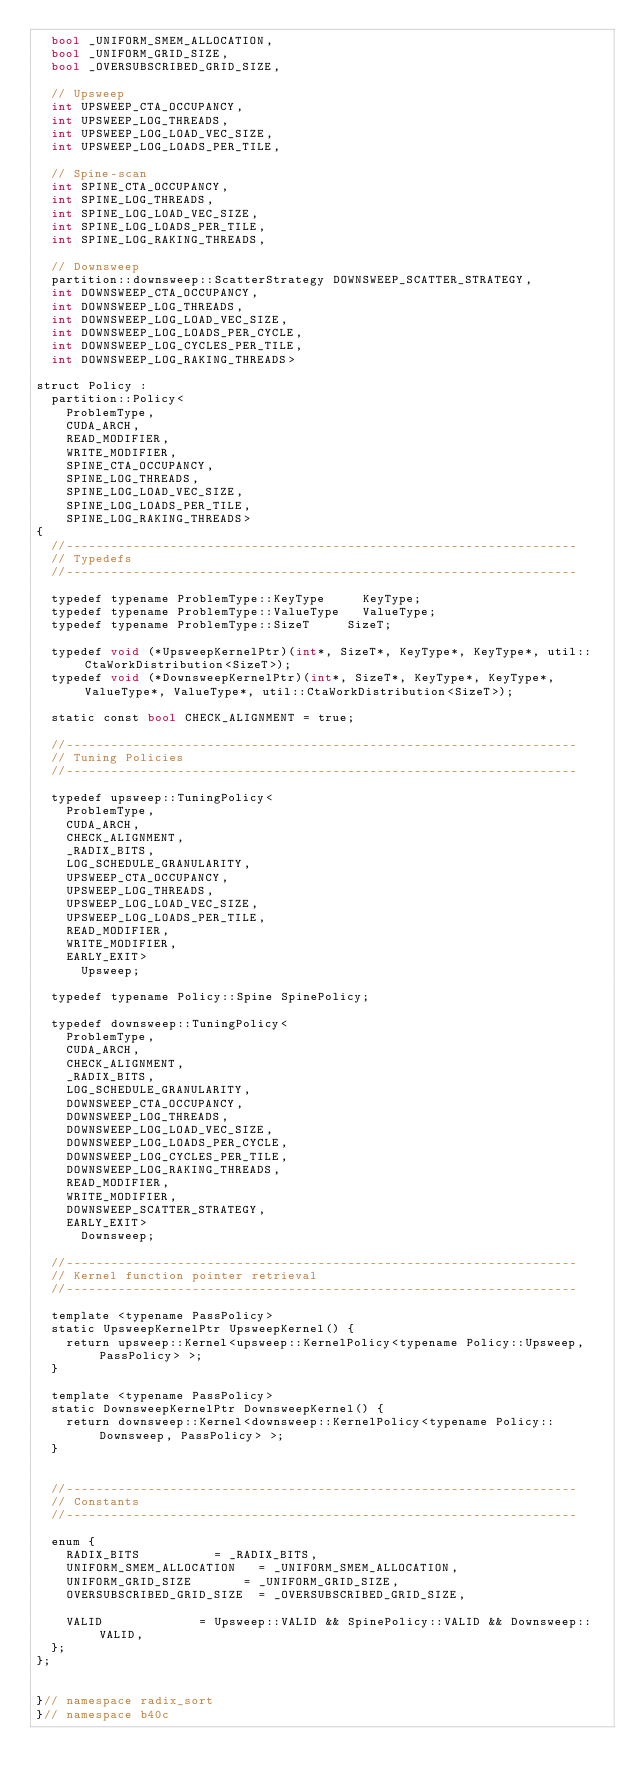<code> <loc_0><loc_0><loc_500><loc_500><_Cuda_>	bool _UNIFORM_SMEM_ALLOCATION,
	bool _UNIFORM_GRID_SIZE,
	bool _OVERSUBSCRIBED_GRID_SIZE,
	
	// Upsweep
	int UPSWEEP_CTA_OCCUPANCY,
	int UPSWEEP_LOG_THREADS,
	int UPSWEEP_LOG_LOAD_VEC_SIZE,
	int UPSWEEP_LOG_LOADS_PER_TILE,
	
	// Spine-scan
	int SPINE_CTA_OCCUPANCY,
	int SPINE_LOG_THREADS,
	int SPINE_LOG_LOAD_VEC_SIZE,
	int SPINE_LOG_LOADS_PER_TILE,
	int SPINE_LOG_RAKING_THREADS,

	// Downsweep
	partition::downsweep::ScatterStrategy DOWNSWEEP_SCATTER_STRATEGY,
	int DOWNSWEEP_CTA_OCCUPANCY,
	int DOWNSWEEP_LOG_THREADS,
	int DOWNSWEEP_LOG_LOAD_VEC_SIZE,
	int DOWNSWEEP_LOG_LOADS_PER_CYCLE,
	int DOWNSWEEP_LOG_CYCLES_PER_TILE,
	int DOWNSWEEP_LOG_RAKING_THREADS>

struct Policy :
	partition::Policy<
		ProblemType,
		CUDA_ARCH,
		READ_MODIFIER,
		WRITE_MODIFIER,
		SPINE_CTA_OCCUPANCY,
		SPINE_LOG_THREADS,
		SPINE_LOG_LOAD_VEC_SIZE,
		SPINE_LOG_LOADS_PER_TILE,
		SPINE_LOG_RAKING_THREADS>
{
	//---------------------------------------------------------------------
	// Typedefs
	//---------------------------------------------------------------------

	typedef typename ProblemType::KeyType 		KeyType;
	typedef typename ProblemType::ValueType		ValueType;
	typedef typename ProblemType::SizeT 		SizeT;

	typedef void (*UpsweepKernelPtr)(int*, SizeT*, KeyType*, KeyType*, util::CtaWorkDistribution<SizeT>);
	typedef void (*DownsweepKernelPtr)(int*, SizeT*, KeyType*, KeyType*, ValueType*, ValueType*, util::CtaWorkDistribution<SizeT>);

	static const bool CHECK_ALIGNMENT = true;

	//---------------------------------------------------------------------
	// Tuning Policies
	//---------------------------------------------------------------------

	typedef upsweep::TuningPolicy<
		ProblemType,
		CUDA_ARCH,
		CHECK_ALIGNMENT,
		_RADIX_BITS,
		LOG_SCHEDULE_GRANULARITY,
		UPSWEEP_CTA_OCCUPANCY,
		UPSWEEP_LOG_THREADS,
		UPSWEEP_LOG_LOAD_VEC_SIZE,
		UPSWEEP_LOG_LOADS_PER_TILE,
		READ_MODIFIER,
		WRITE_MODIFIER,
		EARLY_EXIT>
			Upsweep;

	typedef typename Policy::Spine SpinePolicy;

	typedef downsweep::TuningPolicy<
		ProblemType,
		CUDA_ARCH,
		CHECK_ALIGNMENT,
		_RADIX_BITS,
		LOG_SCHEDULE_GRANULARITY,
		DOWNSWEEP_CTA_OCCUPANCY,
		DOWNSWEEP_LOG_THREADS,
		DOWNSWEEP_LOG_LOAD_VEC_SIZE,
		DOWNSWEEP_LOG_LOADS_PER_CYCLE,
		DOWNSWEEP_LOG_CYCLES_PER_TILE,
		DOWNSWEEP_LOG_RAKING_THREADS,
		READ_MODIFIER,
		WRITE_MODIFIER,
		DOWNSWEEP_SCATTER_STRATEGY,
		EARLY_EXIT>
			Downsweep;

	//---------------------------------------------------------------------
	// Kernel function pointer retrieval
	//---------------------------------------------------------------------

	template <typename PassPolicy>
	static UpsweepKernelPtr UpsweepKernel() {
		return upsweep::Kernel<upsweep::KernelPolicy<typename Policy::Upsweep, PassPolicy> >;
	}

	template <typename PassPolicy>
	static DownsweepKernelPtr DownsweepKernel() {
		return downsweep::Kernel<downsweep::KernelPolicy<typename Policy::Downsweep, PassPolicy> >;
	}


	//---------------------------------------------------------------------
	// Constants
	//---------------------------------------------------------------------

	enum {
		RADIX_BITS					= _RADIX_BITS,
		UNIFORM_SMEM_ALLOCATION 	= _UNIFORM_SMEM_ALLOCATION,
		UNIFORM_GRID_SIZE 			= _UNIFORM_GRID_SIZE,
		OVERSUBSCRIBED_GRID_SIZE	= _OVERSUBSCRIBED_GRID_SIZE,

		VALID 						= Upsweep::VALID && SpinePolicy::VALID && Downsweep::VALID,
	};
};
		

}// namespace radix_sort
}// namespace b40c

</code> 